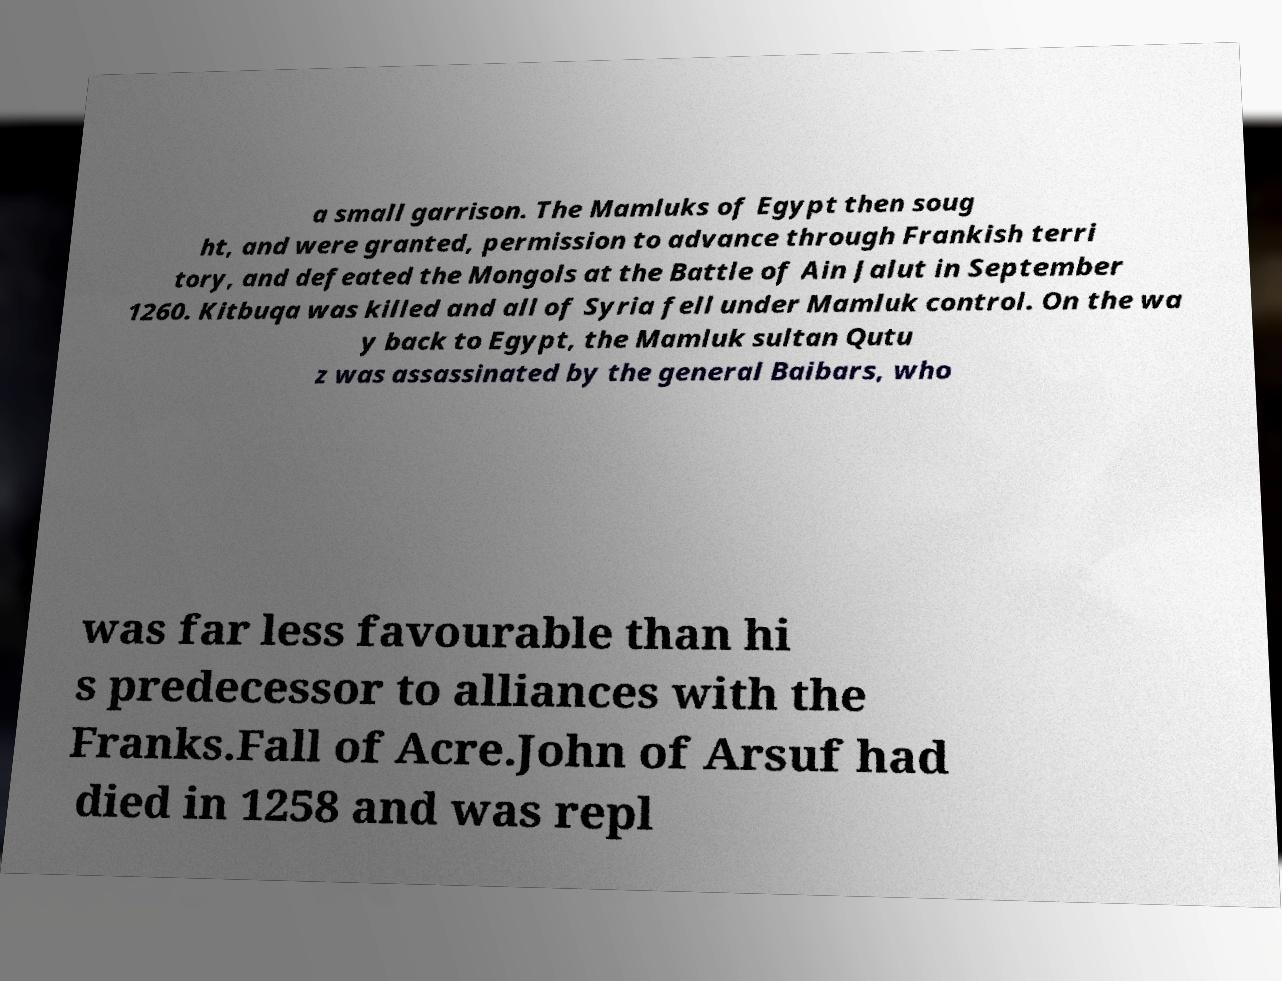For documentation purposes, I need the text within this image transcribed. Could you provide that? a small garrison. The Mamluks of Egypt then soug ht, and were granted, permission to advance through Frankish terri tory, and defeated the Mongols at the Battle of Ain Jalut in September 1260. Kitbuqa was killed and all of Syria fell under Mamluk control. On the wa y back to Egypt, the Mamluk sultan Qutu z was assassinated by the general Baibars, who was far less favourable than hi s predecessor to alliances with the Franks.Fall of Acre.John of Arsuf had died in 1258 and was repl 